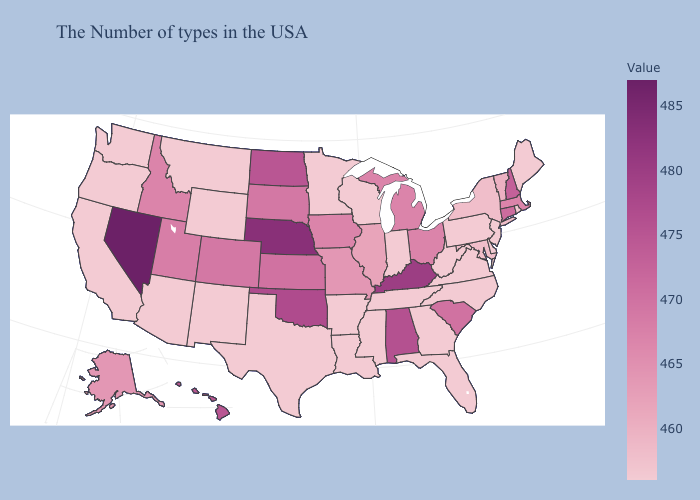Does the map have missing data?
Write a very short answer. No. Among the states that border Montana , does Idaho have the highest value?
Keep it brief. No. Among the states that border New Jersey , which have the lowest value?
Keep it brief. Delaware, Pennsylvania. Does North Dakota have a higher value than Montana?
Answer briefly. Yes. 